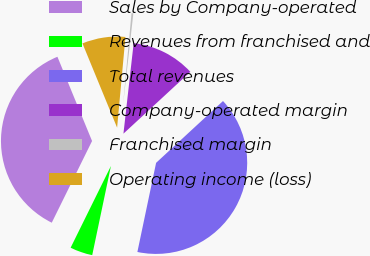<chart> <loc_0><loc_0><loc_500><loc_500><pie_chart><fcel>Sales by Company-operated<fcel>Revenues from franchised and<fcel>Total revenues<fcel>Company-operated margin<fcel>Franchised margin<fcel>Operating income (loss)<nl><fcel>36.5%<fcel>4.0%<fcel>40.17%<fcel>11.34%<fcel>0.33%<fcel>7.67%<nl></chart> 